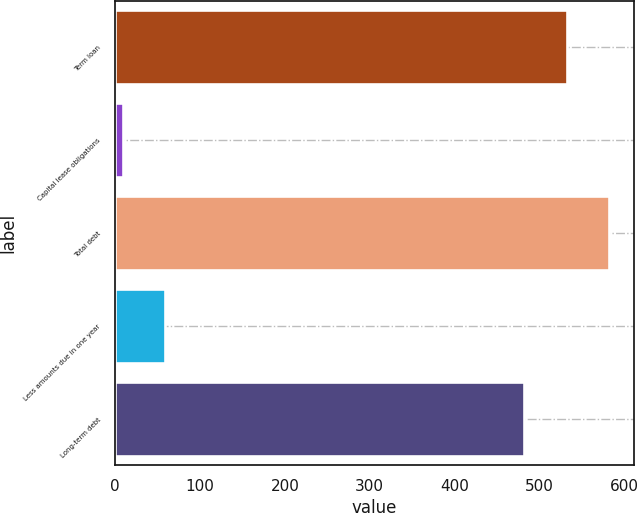<chart> <loc_0><loc_0><loc_500><loc_500><bar_chart><fcel>Term loan<fcel>Capital lease obligations<fcel>Total debt<fcel>Less amounts due in one year<fcel>Long-term debt<nl><fcel>532<fcel>9<fcel>582<fcel>59<fcel>482<nl></chart> 